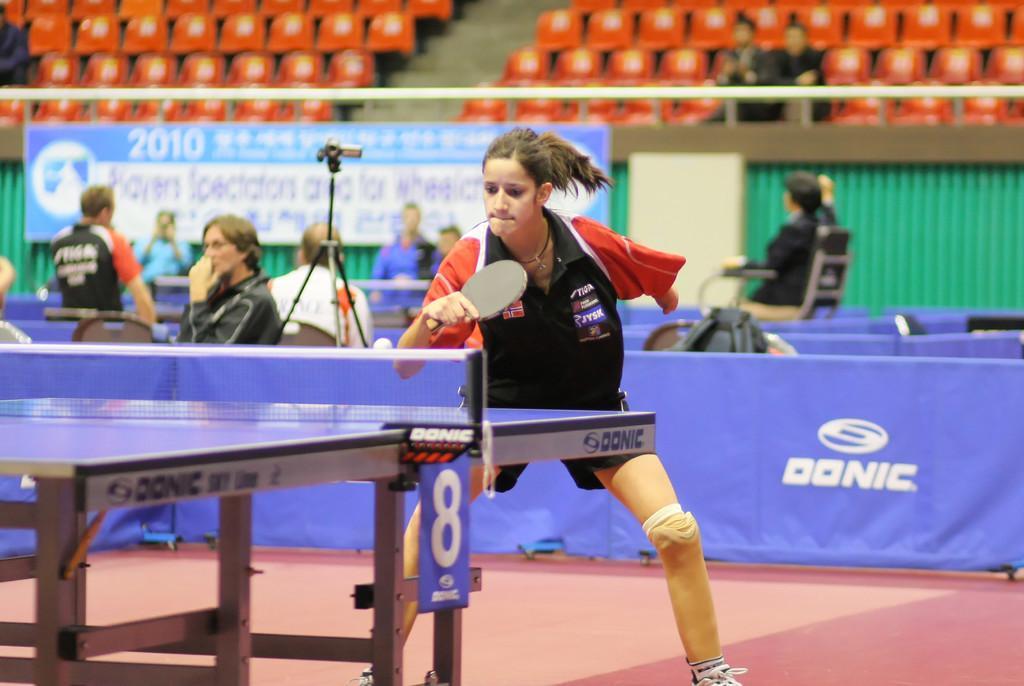Describe this image in one or two sentences. In this image in the center there is one woman standing, and she is playing table tennis. In front of her there is a table, and in the background there are a group of people sitting and also we could see some boards, camera, bags, chairs, railing and some other objects. 